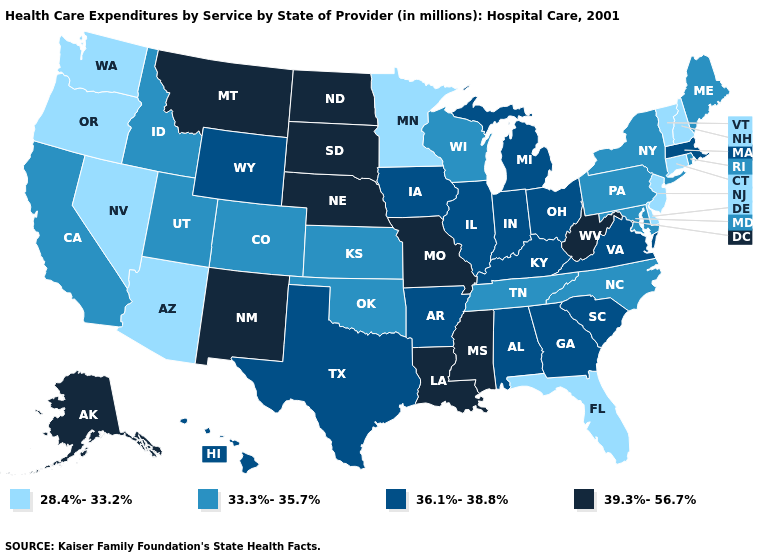Which states have the lowest value in the MidWest?
Answer briefly. Minnesota. Does Indiana have the lowest value in the MidWest?
Concise answer only. No. Name the states that have a value in the range 39.3%-56.7%?
Short answer required. Alaska, Louisiana, Mississippi, Missouri, Montana, Nebraska, New Mexico, North Dakota, South Dakota, West Virginia. What is the value of South Carolina?
Keep it brief. 36.1%-38.8%. What is the highest value in the MidWest ?
Concise answer only. 39.3%-56.7%. What is the highest value in states that border North Carolina?
Short answer required. 36.1%-38.8%. Name the states that have a value in the range 33.3%-35.7%?
Write a very short answer. California, Colorado, Idaho, Kansas, Maine, Maryland, New York, North Carolina, Oklahoma, Pennsylvania, Rhode Island, Tennessee, Utah, Wisconsin. What is the value of Florida?
Concise answer only. 28.4%-33.2%. Name the states that have a value in the range 33.3%-35.7%?
Short answer required. California, Colorado, Idaho, Kansas, Maine, Maryland, New York, North Carolina, Oklahoma, Pennsylvania, Rhode Island, Tennessee, Utah, Wisconsin. What is the value of Indiana?
Quick response, please. 36.1%-38.8%. What is the lowest value in the MidWest?
Keep it brief. 28.4%-33.2%. Does the first symbol in the legend represent the smallest category?
Short answer required. Yes. What is the lowest value in the MidWest?
Answer briefly. 28.4%-33.2%. What is the value of Pennsylvania?
Quick response, please. 33.3%-35.7%. 